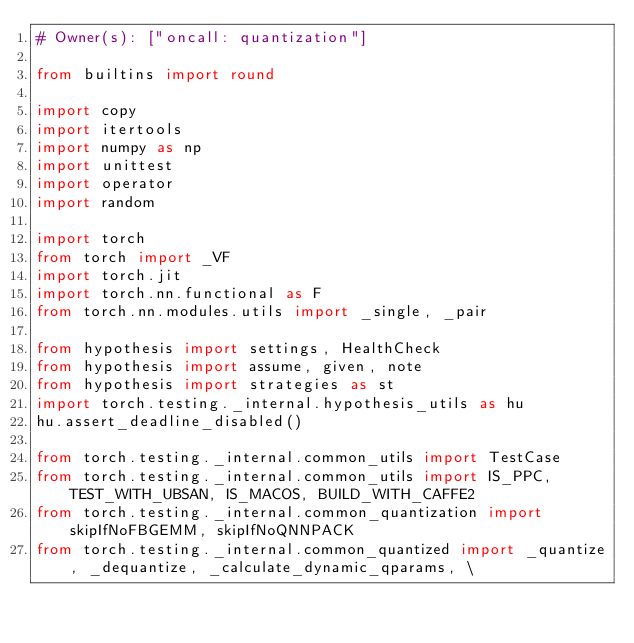<code> <loc_0><loc_0><loc_500><loc_500><_Python_># Owner(s): ["oncall: quantization"]

from builtins import round

import copy
import itertools
import numpy as np
import unittest
import operator
import random

import torch
from torch import _VF
import torch.jit
import torch.nn.functional as F
from torch.nn.modules.utils import _single, _pair

from hypothesis import settings, HealthCheck
from hypothesis import assume, given, note
from hypothesis import strategies as st
import torch.testing._internal.hypothesis_utils as hu
hu.assert_deadline_disabled()

from torch.testing._internal.common_utils import TestCase
from torch.testing._internal.common_utils import IS_PPC, TEST_WITH_UBSAN, IS_MACOS, BUILD_WITH_CAFFE2
from torch.testing._internal.common_quantization import skipIfNoFBGEMM, skipIfNoQNNPACK
from torch.testing._internal.common_quantized import _quantize, _dequantize, _calculate_dynamic_qparams, \</code> 